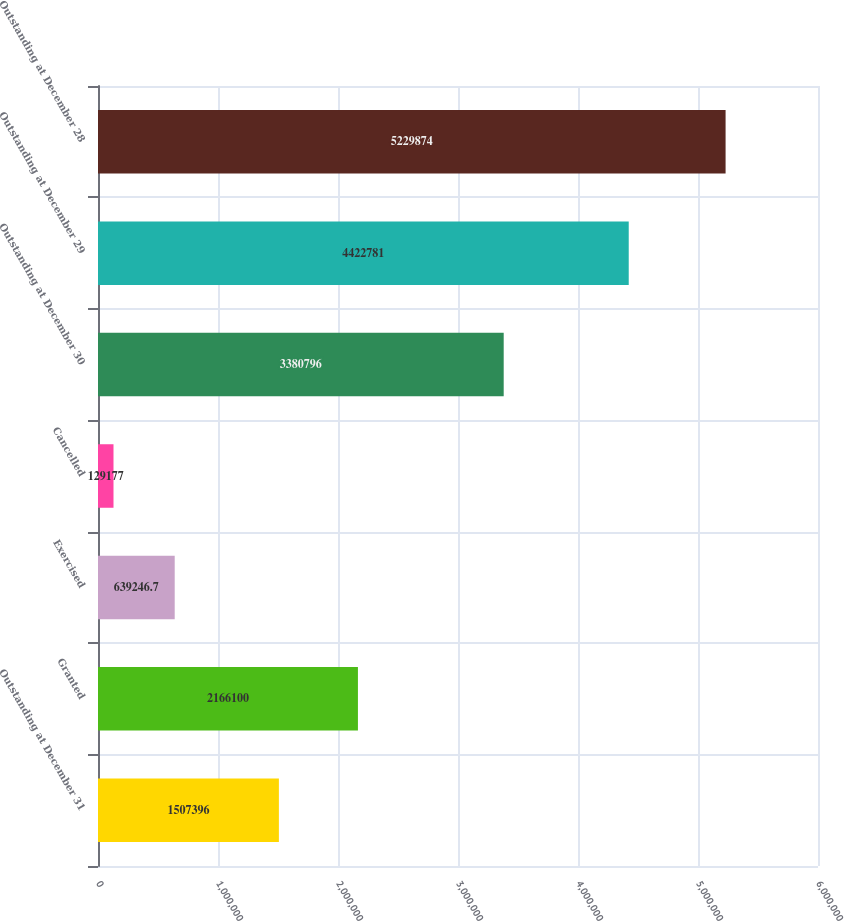Convert chart. <chart><loc_0><loc_0><loc_500><loc_500><bar_chart><fcel>Outstanding at December 31<fcel>Granted<fcel>Exercised<fcel>Cancelled<fcel>Outstanding at December 30<fcel>Outstanding at December 29<fcel>Outstanding at December 28<nl><fcel>1.5074e+06<fcel>2.1661e+06<fcel>639247<fcel>129177<fcel>3.3808e+06<fcel>4.42278e+06<fcel>5.22987e+06<nl></chart> 